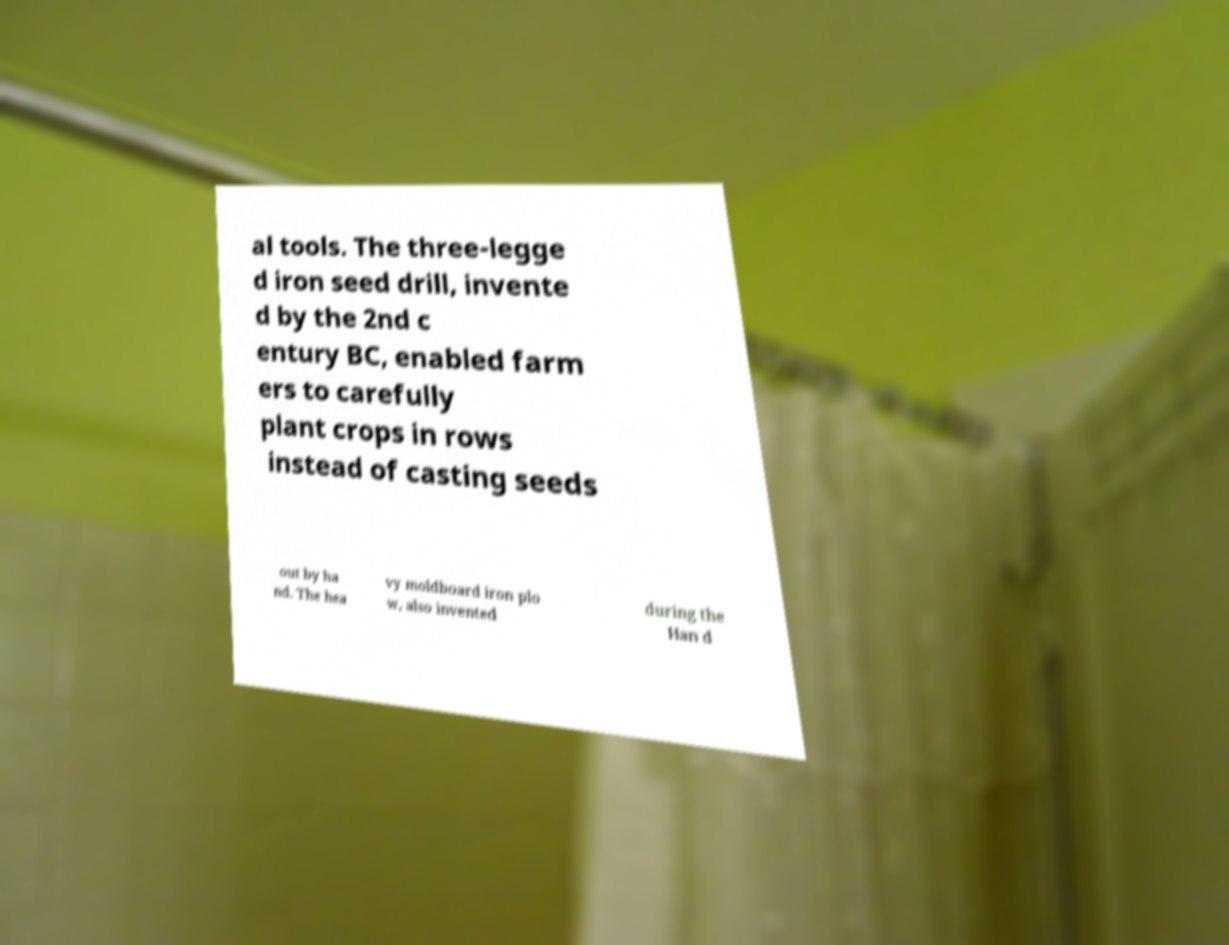There's text embedded in this image that I need extracted. Can you transcribe it verbatim? al tools. The three-legge d iron seed drill, invente d by the 2nd c entury BC, enabled farm ers to carefully plant crops in rows instead of casting seeds out by ha nd. The hea vy moldboard iron plo w, also invented during the Han d 